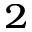<formula> <loc_0><loc_0><loc_500><loc_500>^ { 2 }</formula> 